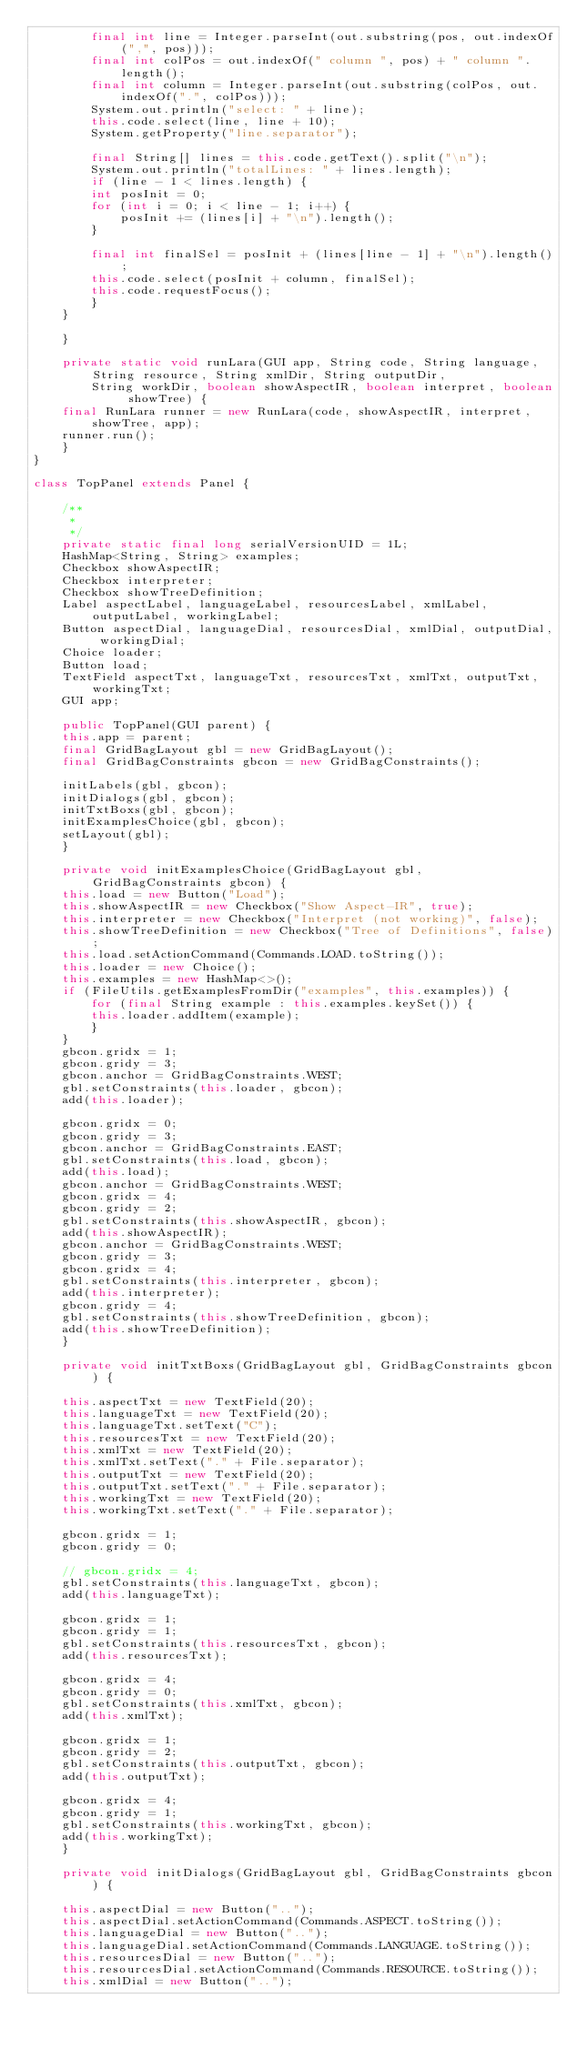Convert code to text. <code><loc_0><loc_0><loc_500><loc_500><_Java_>	    final int line = Integer.parseInt(out.substring(pos, out.indexOf(",", pos)));
	    final int colPos = out.indexOf(" column ", pos) + " column ".length();
	    final int column = Integer.parseInt(out.substring(colPos, out.indexOf(".", colPos)));
	    System.out.println("select: " + line);
	    this.code.select(line, line + 10);
	    System.getProperty("line.separator");

	    final String[] lines = this.code.getText().split("\n");
	    System.out.println("totalLines: " + lines.length);
	    if (line - 1 < lines.length) {
		int posInit = 0;
		for (int i = 0; i < line - 1; i++) {
		    posInit += (lines[i] + "\n").length();
		}

		final int finalSel = posInit + (lines[line - 1] + "\n").length();
		this.code.select(posInit + column, finalSel);
		this.code.requestFocus();
	    }
	}

    }

    private static void runLara(GUI app, String code, String language, String resource, String xmlDir, String outputDir,
	    String workDir, boolean showAspectIR, boolean interpret, boolean showTree) {
	final RunLara runner = new RunLara(code, showAspectIR, interpret, showTree, app);
	runner.run();
    }
}

class TopPanel extends Panel {

    /**
     * 
     */
    private static final long serialVersionUID = 1L;
    HashMap<String, String> examples;
    Checkbox showAspectIR;
    Checkbox interpreter;
    Checkbox showTreeDefinition;
    Label aspectLabel, languageLabel, resourcesLabel, xmlLabel, outputLabel, workingLabel;
    Button aspectDial, languageDial, resourcesDial, xmlDial, outputDial, workingDial;
    Choice loader;
    Button load;
    TextField aspectTxt, languageTxt, resourcesTxt, xmlTxt, outputTxt, workingTxt;
    GUI app;

    public TopPanel(GUI parent) {
	this.app = parent;
	final GridBagLayout gbl = new GridBagLayout();
	final GridBagConstraints gbcon = new GridBagConstraints();

	initLabels(gbl, gbcon);
	initDialogs(gbl, gbcon);
	initTxtBoxs(gbl, gbcon);
	initExamplesChoice(gbl, gbcon);
	setLayout(gbl);
    }

    private void initExamplesChoice(GridBagLayout gbl, GridBagConstraints gbcon) {
	this.load = new Button("Load");
	this.showAspectIR = new Checkbox("Show Aspect-IR", true);
	this.interpreter = new Checkbox("Interpret (not working)", false);
	this.showTreeDefinition = new Checkbox("Tree of Definitions", false);
	this.load.setActionCommand(Commands.LOAD.toString());
	this.loader = new Choice();
	this.examples = new HashMap<>();
	if (FileUtils.getExamplesFromDir("examples", this.examples)) {
	    for (final String example : this.examples.keySet()) {
		this.loader.addItem(example);
	    }
	}
	gbcon.gridx = 1;
	gbcon.gridy = 3;
	gbcon.anchor = GridBagConstraints.WEST;
	gbl.setConstraints(this.loader, gbcon);
	add(this.loader);

	gbcon.gridx = 0;
	gbcon.gridy = 3;
	gbcon.anchor = GridBagConstraints.EAST;
	gbl.setConstraints(this.load, gbcon);
	add(this.load);
	gbcon.anchor = GridBagConstraints.WEST;
	gbcon.gridx = 4;
	gbcon.gridy = 2;
	gbl.setConstraints(this.showAspectIR, gbcon);
	add(this.showAspectIR);
	gbcon.anchor = GridBagConstraints.WEST;
	gbcon.gridy = 3;
	gbcon.gridx = 4;
	gbl.setConstraints(this.interpreter, gbcon);
	add(this.interpreter);
	gbcon.gridy = 4;
	gbl.setConstraints(this.showTreeDefinition, gbcon);
	add(this.showTreeDefinition);
    }

    private void initTxtBoxs(GridBagLayout gbl, GridBagConstraints gbcon) {

	this.aspectTxt = new TextField(20);
	this.languageTxt = new TextField(20);
	this.languageTxt.setText("C");
	this.resourcesTxt = new TextField(20);
	this.xmlTxt = new TextField(20);
	this.xmlTxt.setText("." + File.separator);
	this.outputTxt = new TextField(20);
	this.outputTxt.setText("." + File.separator);
	this.workingTxt = new TextField(20);
	this.workingTxt.setText("." + File.separator);

	gbcon.gridx = 1;
	gbcon.gridy = 0;

	// gbcon.gridx = 4;
	gbl.setConstraints(this.languageTxt, gbcon);
	add(this.languageTxt);

	gbcon.gridx = 1;
	gbcon.gridy = 1;
	gbl.setConstraints(this.resourcesTxt, gbcon);
	add(this.resourcesTxt);

	gbcon.gridx = 4;
	gbcon.gridy = 0;
	gbl.setConstraints(this.xmlTxt, gbcon);
	add(this.xmlTxt);

	gbcon.gridx = 1;
	gbcon.gridy = 2;
	gbl.setConstraints(this.outputTxt, gbcon);
	add(this.outputTxt);

	gbcon.gridx = 4;
	gbcon.gridy = 1;
	gbl.setConstraints(this.workingTxt, gbcon);
	add(this.workingTxt);
    }

    private void initDialogs(GridBagLayout gbl, GridBagConstraints gbcon) {

	this.aspectDial = new Button("..");
	this.aspectDial.setActionCommand(Commands.ASPECT.toString());
	this.languageDial = new Button("..");
	this.languageDial.setActionCommand(Commands.LANGUAGE.toString());
	this.resourcesDial = new Button("..");
	this.resourcesDial.setActionCommand(Commands.RESOURCE.toString());
	this.xmlDial = new Button("..");</code> 